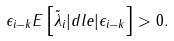<formula> <loc_0><loc_0><loc_500><loc_500>\epsilon _ { i - k } E \left [ \tilde { \lambda } _ { i } | d l e | \epsilon _ { i - k } \right ] > 0 .</formula> 